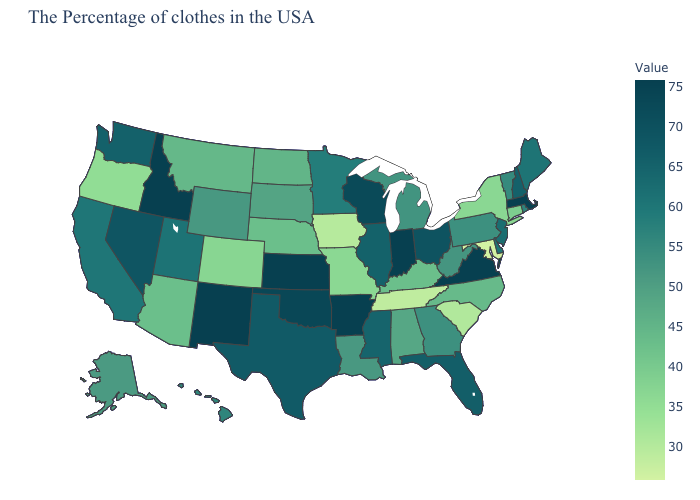Does Massachusetts have the highest value in the Northeast?
Be succinct. Yes. Does New Mexico have the highest value in the USA?
Short answer required. Yes. Is the legend a continuous bar?
Quick response, please. Yes. Does Delaware have a lower value than Iowa?
Short answer required. No. Among the states that border New York , which have the lowest value?
Write a very short answer. Connecticut. Which states have the highest value in the USA?
Give a very brief answer. Massachusetts, Virginia, Arkansas, Kansas, New Mexico, Idaho. Among the states that border North Carolina , does Georgia have the lowest value?
Be succinct. No. 